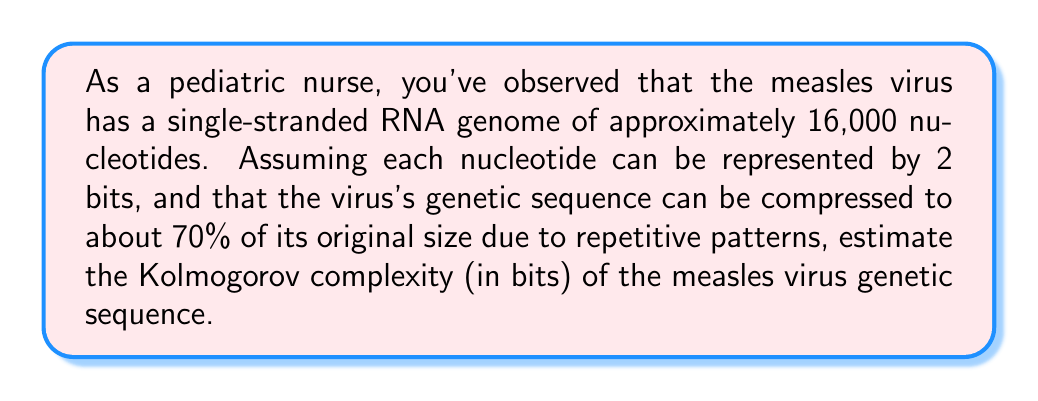Show me your answer to this math problem. To estimate the Kolmogorov complexity of the measles virus genetic sequence, we'll follow these steps:

1. Calculate the total bits in the uncompressed sequence:
   $$ \text{Total bits} = \text{Number of nucleotides} \times \text{Bits per nucleotide} $$
   $$ \text{Total bits} = 16,000 \times 2 = 32,000 \text{ bits} $$

2. Calculate the compressed size:
   The sequence can be compressed to 70% of its original size.
   $$ \text{Compressed size} = \text{Total bits} \times 0.70 $$
   $$ \text{Compressed size} = 32,000 \times 0.70 = 22,400 \text{ bits} $$

3. Estimate the Kolmogorov complexity:
   The Kolmogorov complexity is approximately equal to the compressed size of the sequence, as it represents the shortest possible description of the sequence.
   $$ K(\text{measles virus sequence}) \approx 22,400 \text{ bits} $$

This estimate assumes that the 70% compression captures most of the regularity in the genetic sequence. The actual Kolmogorov complexity might be slightly lower if there are more complex patterns that this simple compression estimate doesn't capture.
Answer: The estimated Kolmogorov complexity of the measles virus genetic sequence is approximately 22,400 bits. 